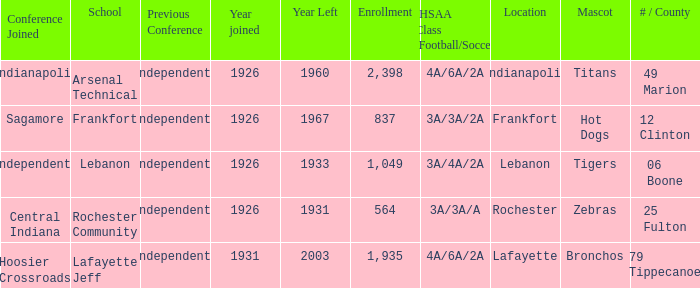What is the highest enrollment for rochester community school? 564.0. 